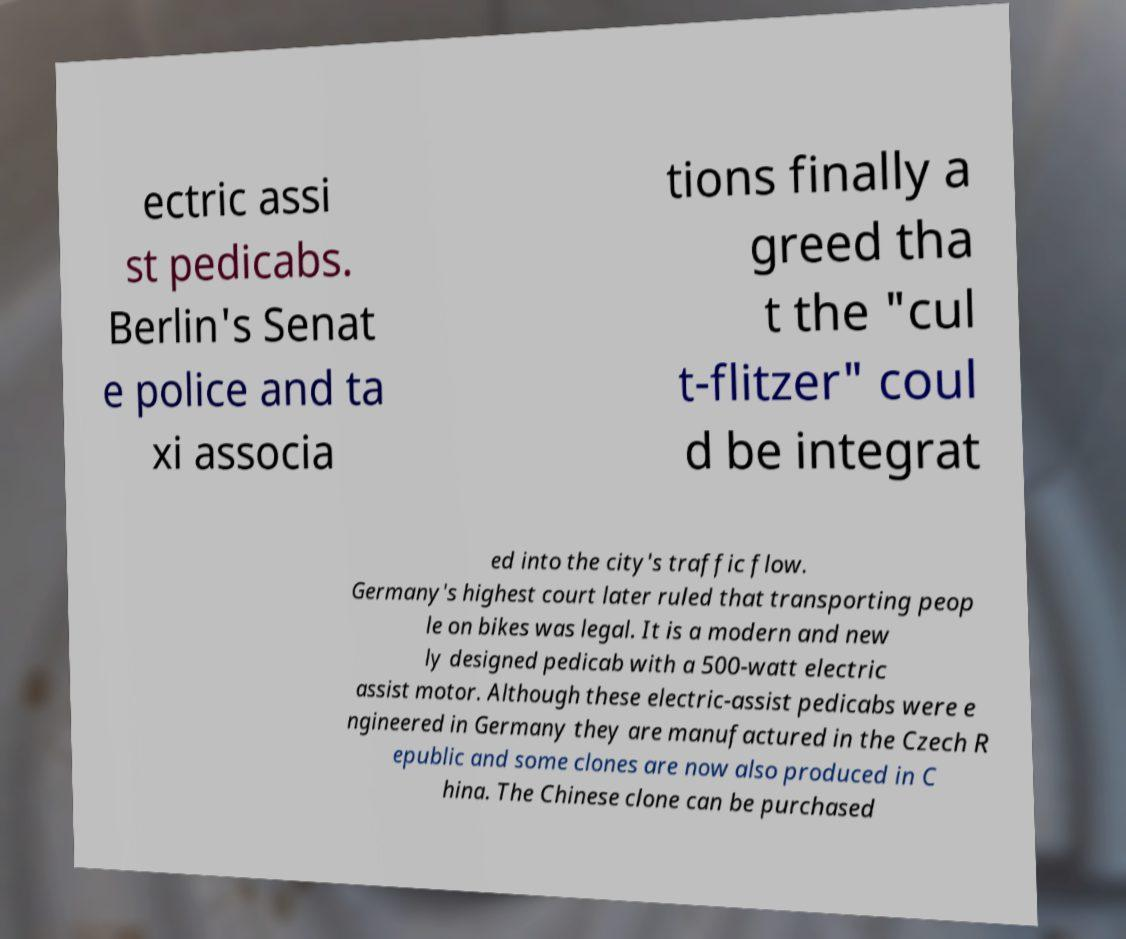Can you accurately transcribe the text from the provided image for me? ectric assi st pedicabs. Berlin's Senat e police and ta xi associa tions finally a greed tha t the "cul t-flitzer" coul d be integrat ed into the city's traffic flow. Germany's highest court later ruled that transporting peop le on bikes was legal. It is a modern and new ly designed pedicab with a 500-watt electric assist motor. Although these electric-assist pedicabs were e ngineered in Germany they are manufactured in the Czech R epublic and some clones are now also produced in C hina. The Chinese clone can be purchased 